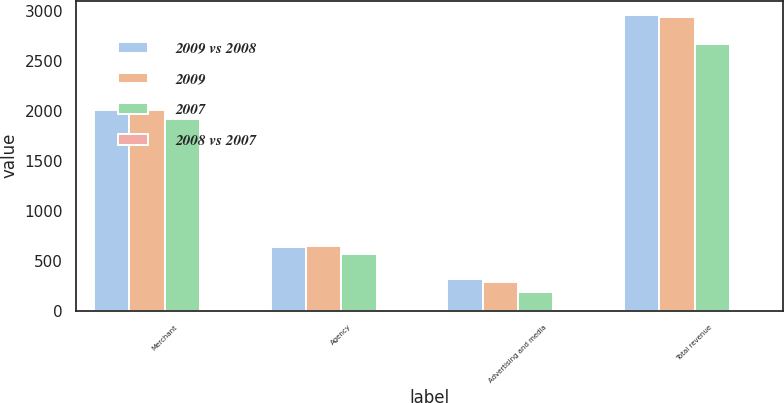<chart> <loc_0><loc_0><loc_500><loc_500><stacked_bar_chart><ecel><fcel>Merchant<fcel>Agency<fcel>Advertising and media<fcel>Total revenue<nl><fcel>2009 vs 2008<fcel>2005<fcel>639<fcel>311<fcel>2955<nl><fcel>2009<fcel>2004<fcel>651<fcel>282<fcel>2937<nl><fcel>2007<fcel>1915<fcel>567<fcel>183<fcel>2665<nl><fcel>2008 vs 2007<fcel>0<fcel>2<fcel>10<fcel>1<nl></chart> 